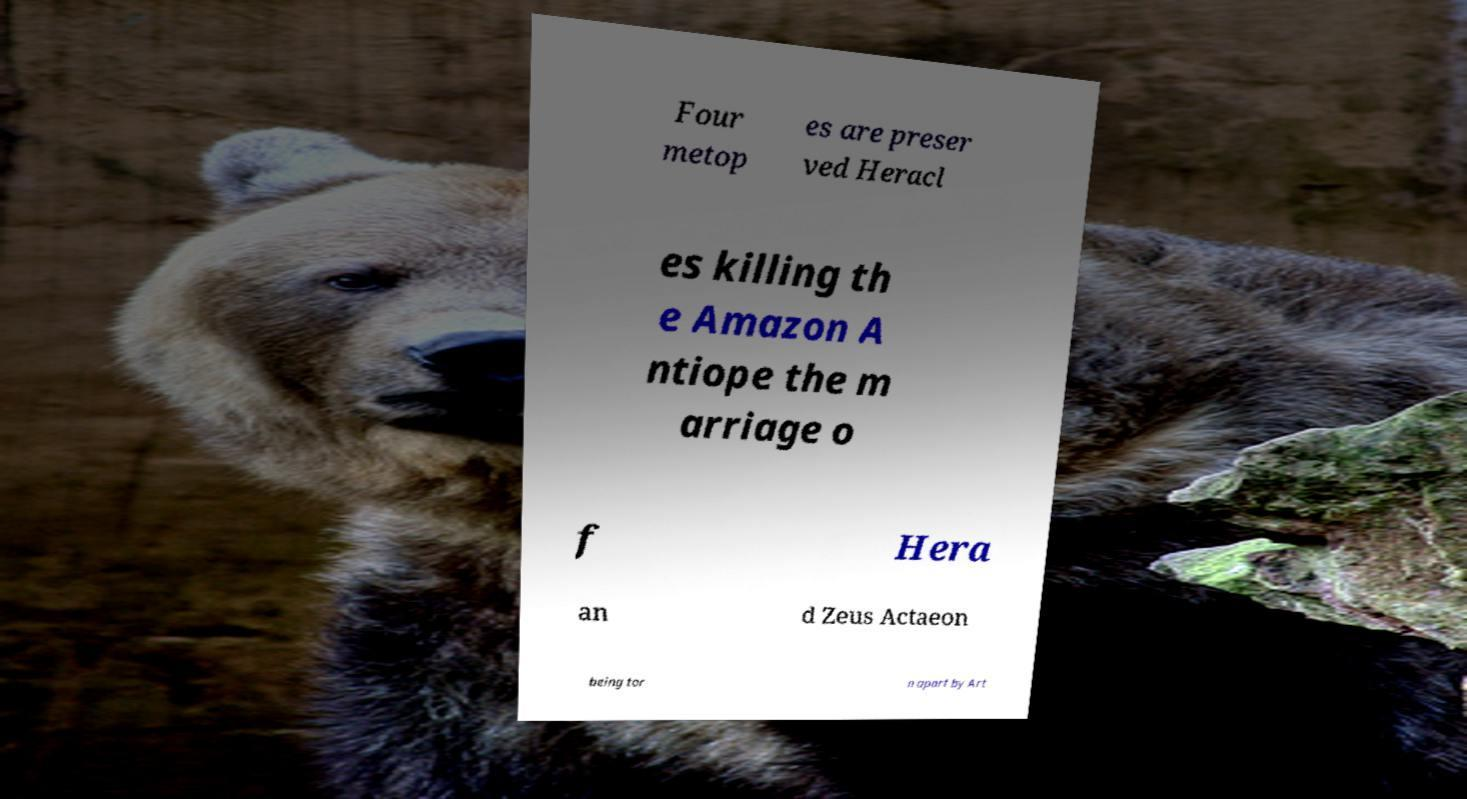Could you assist in decoding the text presented in this image and type it out clearly? Four metop es are preser ved Heracl es killing th e Amazon A ntiope the m arriage o f Hera an d Zeus Actaeon being tor n apart by Art 